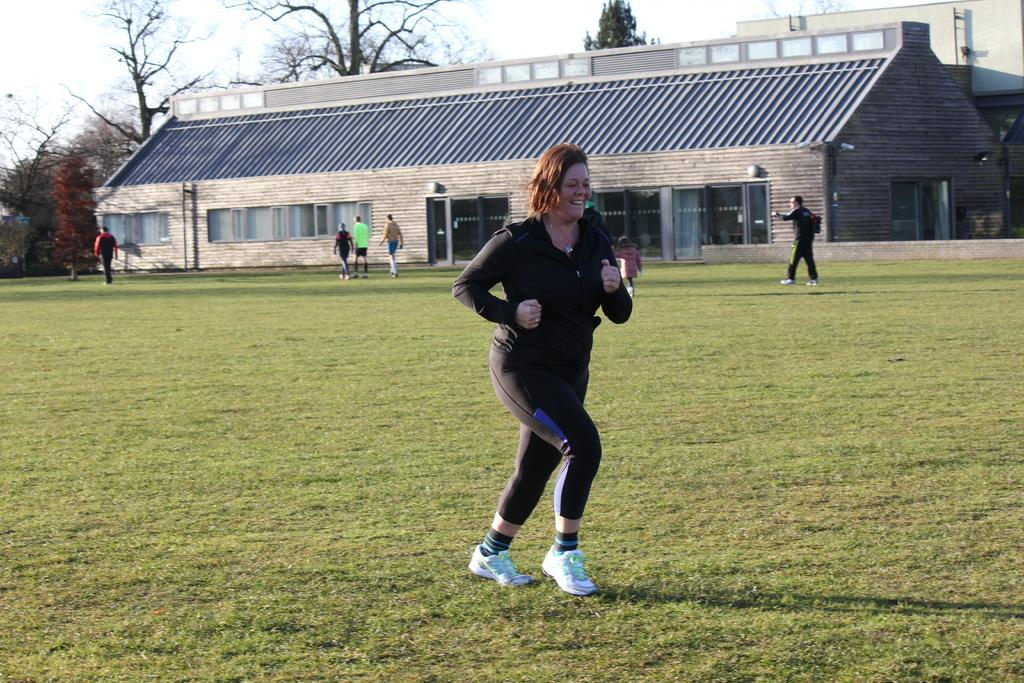Who is the main subject in the image? There is a lady standing in the center of the image. What can be seen in the background of the image? There are people, sheds, trees, and sky visible in the background of the image. What is the ground made of in the image? There is grass at the bottom of the image. How does the lady curve her body in the image? The lady does not curve her body in the image; she is standing straight. Are there any bears visible in the image? No, there are no bears present in the image. 